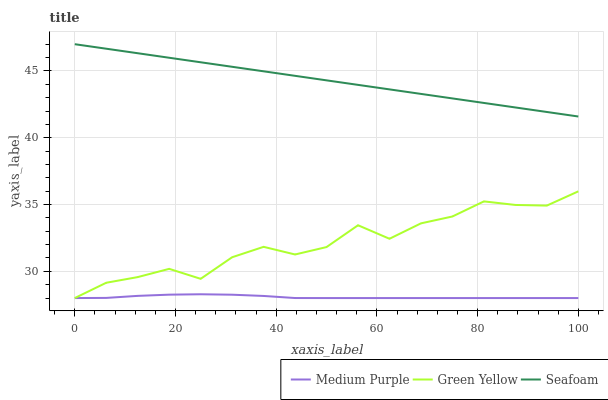Does Medium Purple have the minimum area under the curve?
Answer yes or no. Yes. Does Seafoam have the maximum area under the curve?
Answer yes or no. Yes. Does Green Yellow have the minimum area under the curve?
Answer yes or no. No. Does Green Yellow have the maximum area under the curve?
Answer yes or no. No. Is Seafoam the smoothest?
Answer yes or no. Yes. Is Green Yellow the roughest?
Answer yes or no. Yes. Is Green Yellow the smoothest?
Answer yes or no. No. Is Seafoam the roughest?
Answer yes or no. No. Does Medium Purple have the lowest value?
Answer yes or no. Yes. Does Seafoam have the lowest value?
Answer yes or no. No. Does Seafoam have the highest value?
Answer yes or no. Yes. Does Green Yellow have the highest value?
Answer yes or no. No. Is Medium Purple less than Seafoam?
Answer yes or no. Yes. Is Seafoam greater than Medium Purple?
Answer yes or no. Yes. Does Green Yellow intersect Medium Purple?
Answer yes or no. Yes. Is Green Yellow less than Medium Purple?
Answer yes or no. No. Is Green Yellow greater than Medium Purple?
Answer yes or no. No. Does Medium Purple intersect Seafoam?
Answer yes or no. No. 